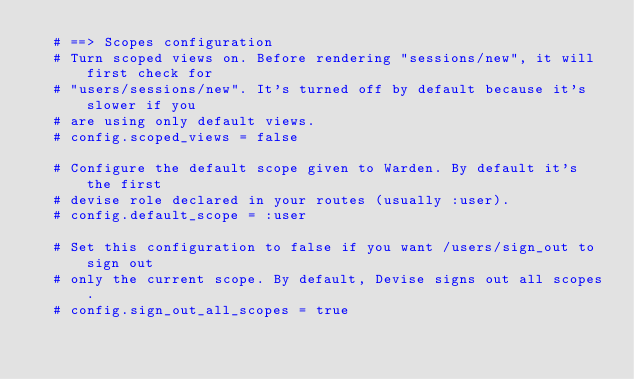<code> <loc_0><loc_0><loc_500><loc_500><_Ruby_>  # ==> Scopes configuration
  # Turn scoped views on. Before rendering "sessions/new", it will first check for
  # "users/sessions/new". It's turned off by default because it's slower if you
  # are using only default views.
  # config.scoped_views = false

  # Configure the default scope given to Warden. By default it's the first
  # devise role declared in your routes (usually :user).
  # config.default_scope = :user

  # Set this configuration to false if you want /users/sign_out to sign out
  # only the current scope. By default, Devise signs out all scopes.
  # config.sign_out_all_scopes = true
</code> 